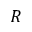<formula> <loc_0><loc_0><loc_500><loc_500>R</formula> 